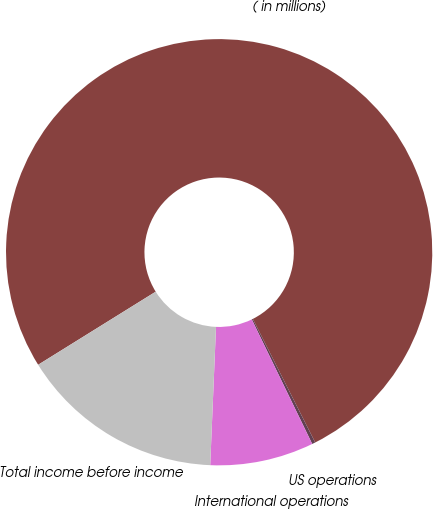<chart> <loc_0><loc_0><loc_500><loc_500><pie_chart><fcel>( in millions)<fcel>US operations<fcel>International operations<fcel>Total income before income<nl><fcel>76.41%<fcel>0.25%<fcel>7.86%<fcel>15.48%<nl></chart> 